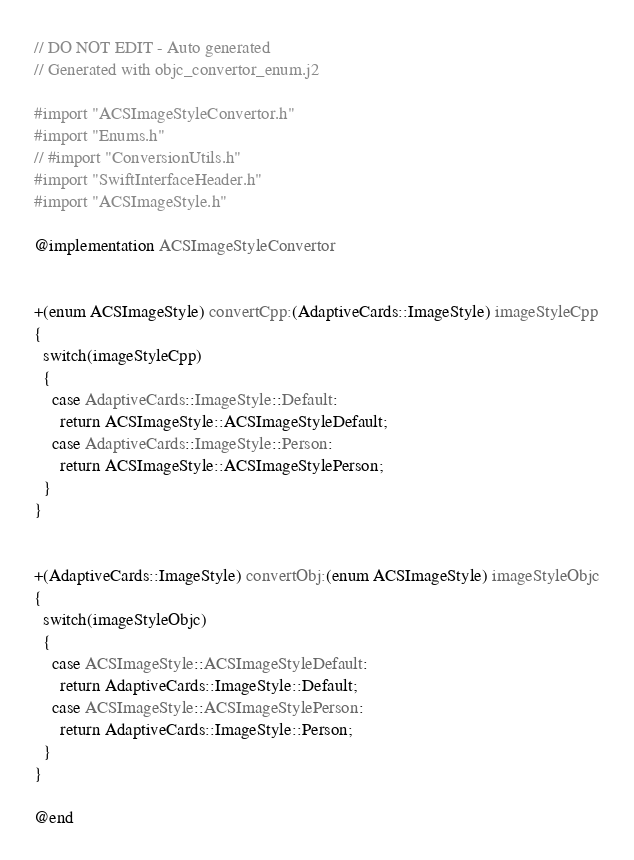Convert code to text. <code><loc_0><loc_0><loc_500><loc_500><_ObjectiveC_>// DO NOT EDIT - Auto generated
// Generated with objc_convertor_enum.j2

#import "ACSImageStyleConvertor.h"
#import "Enums.h"
// #import "ConversionUtils.h"
#import "SwiftInterfaceHeader.h"
#import "ACSImageStyle.h"

@implementation ACSImageStyleConvertor


+(enum ACSImageStyle) convertCpp:(AdaptiveCards::ImageStyle) imageStyleCpp
{
  switch(imageStyleCpp)
  {
    case AdaptiveCards::ImageStyle::Default:
      return ACSImageStyle::ACSImageStyleDefault;
    case AdaptiveCards::ImageStyle::Person:
      return ACSImageStyle::ACSImageStylePerson;
  }
}


+(AdaptiveCards::ImageStyle) convertObj:(enum ACSImageStyle) imageStyleObjc
{
  switch(imageStyleObjc)
  {
    case ACSImageStyle::ACSImageStyleDefault:
      return AdaptiveCards::ImageStyle::Default;
    case ACSImageStyle::ACSImageStylePerson:
      return AdaptiveCards::ImageStyle::Person;
  }
}

@end
</code> 